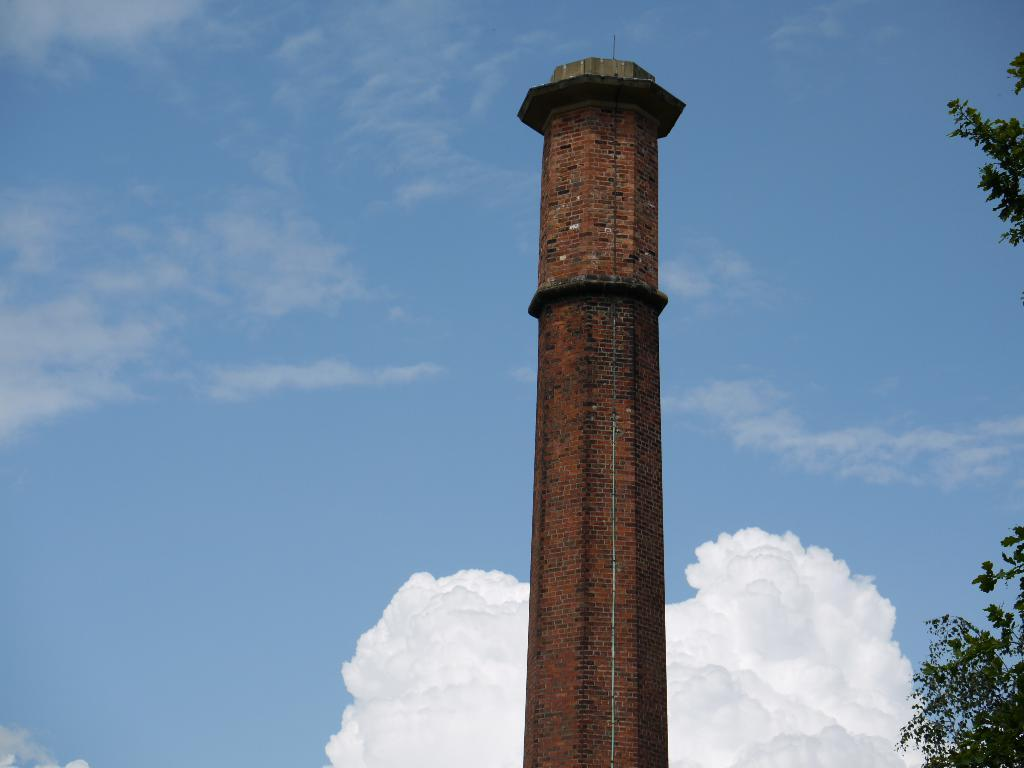What is the main structure in the foreground of the image? There is a building tower in the foreground of the image. What type of vegetation can be seen on the right side of the image? There is a tree on the right side of the image. What is visible in the background of the image? The sky is visible in the background of the image. What can be observed in the sky? There are clouds in the sky. What is the selection of units available for purchase in the image? There is no reference to units or purchasing in the image; it features a building tower, a tree, and clouds in the sky. 